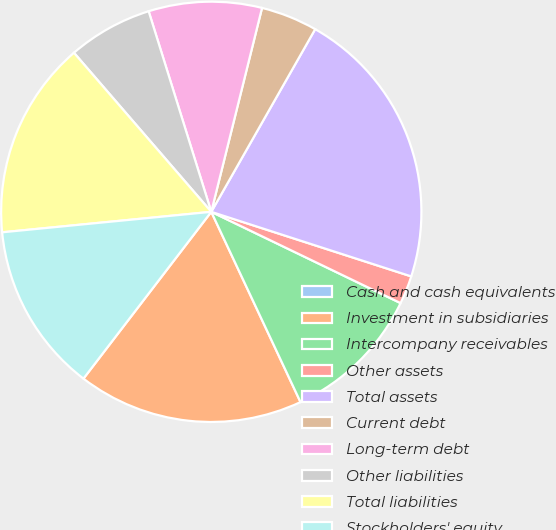Convert chart. <chart><loc_0><loc_0><loc_500><loc_500><pie_chart><fcel>Cash and cash equivalents<fcel>Investment in subsidiaries<fcel>Intercompany receivables<fcel>Other assets<fcel>Total assets<fcel>Current debt<fcel>Long-term debt<fcel>Other liabilities<fcel>Total liabilities<fcel>Stockholders' equity<nl><fcel>0.0%<fcel>17.39%<fcel>10.87%<fcel>2.18%<fcel>21.74%<fcel>4.35%<fcel>8.7%<fcel>6.52%<fcel>15.22%<fcel>13.04%<nl></chart> 